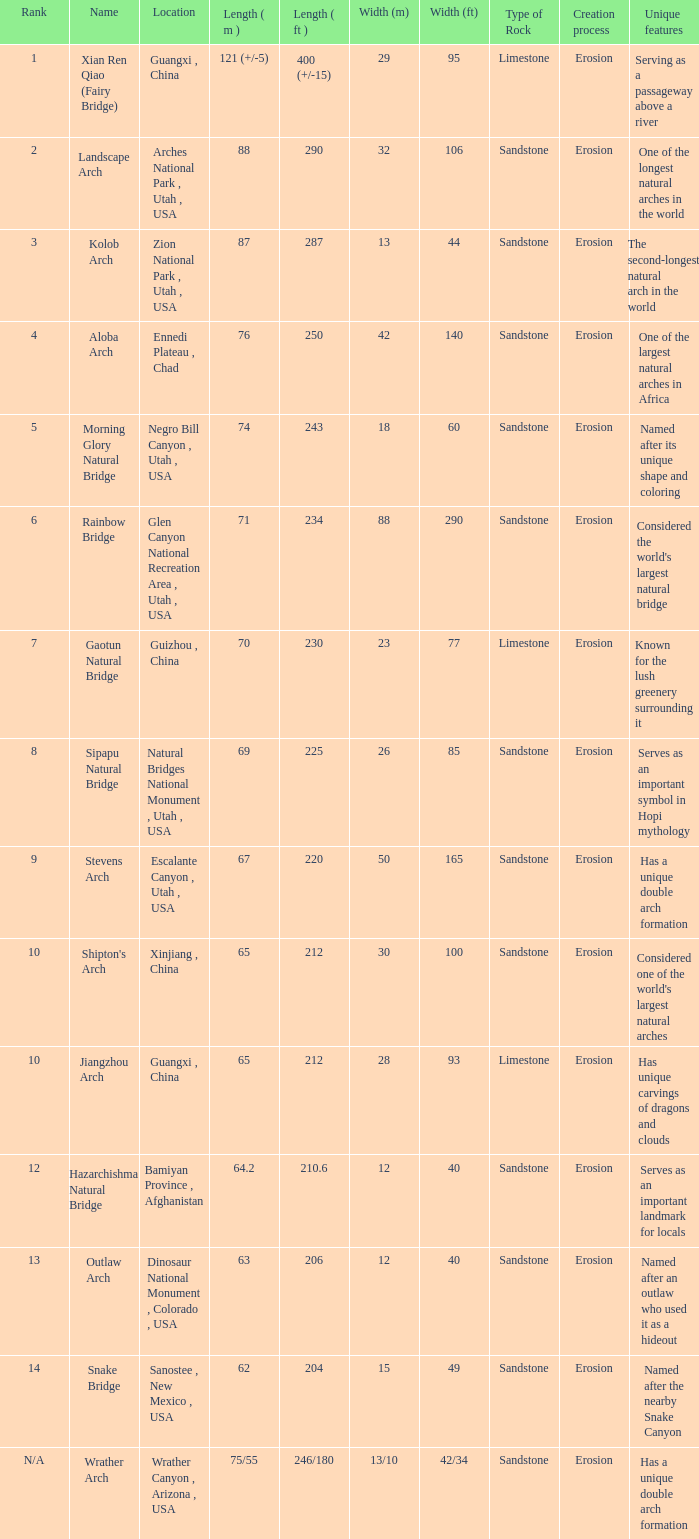What is the length in feet of the Jiangzhou arch? 212.0. 